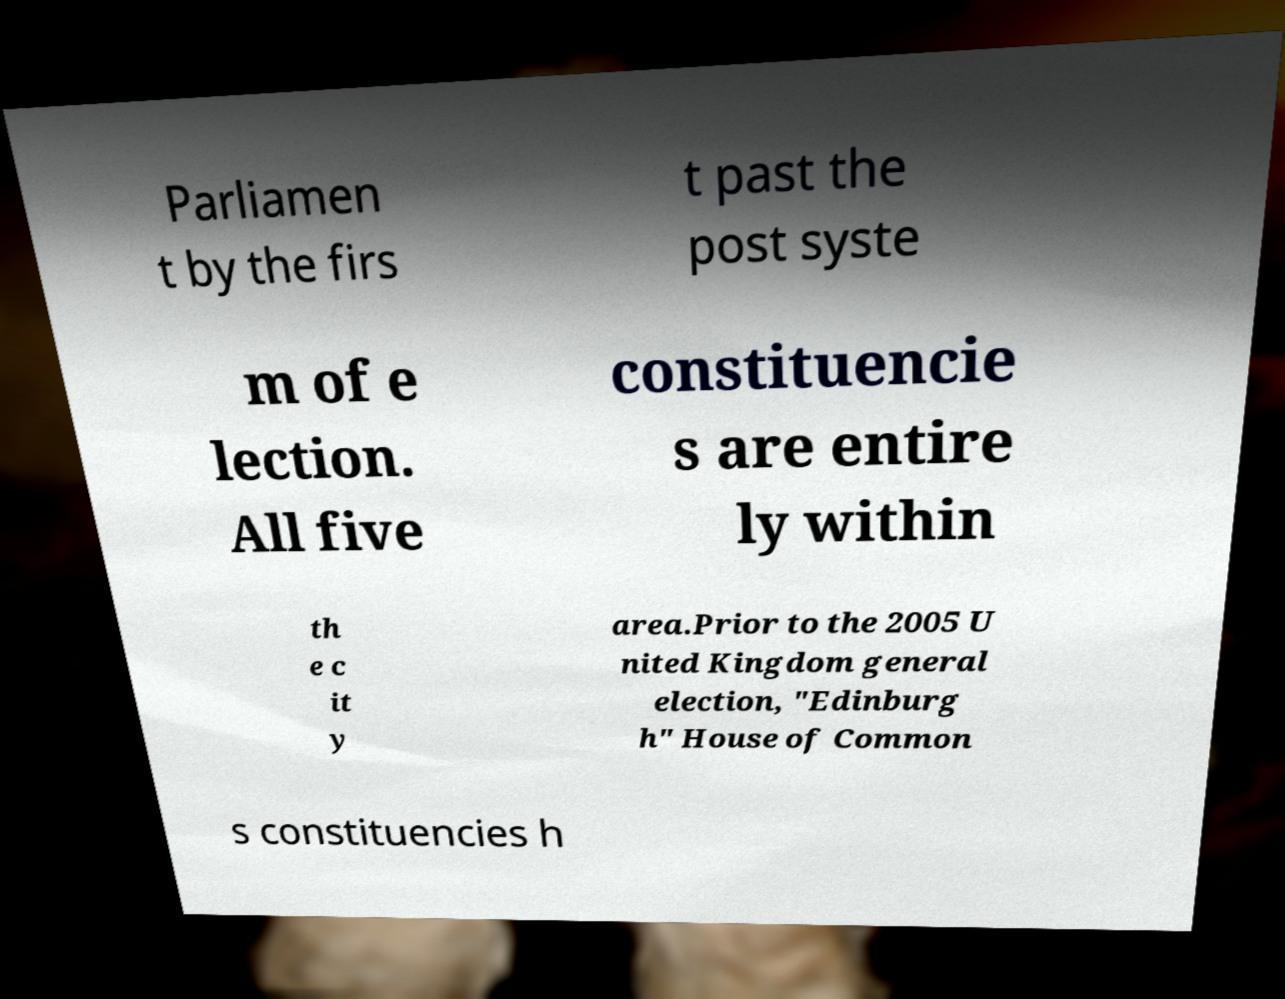What messages or text are displayed in this image? I need them in a readable, typed format. Parliamen t by the firs t past the post syste m of e lection. All five constituencie s are entire ly within th e c it y area.Prior to the 2005 U nited Kingdom general election, "Edinburg h" House of Common s constituencies h 